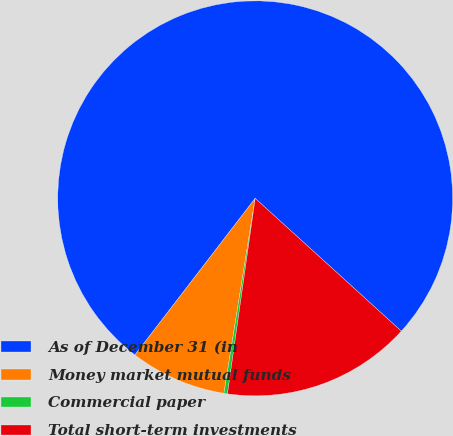Convert chart to OTSL. <chart><loc_0><loc_0><loc_500><loc_500><pie_chart><fcel>As of December 31 (in<fcel>Money market mutual funds<fcel>Commercial paper<fcel>Total short-term investments<nl><fcel>76.32%<fcel>7.89%<fcel>0.29%<fcel>15.5%<nl></chart> 